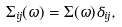<formula> <loc_0><loc_0><loc_500><loc_500>\Sigma _ { i j } ( \omega ) = \Sigma ( \omega ) \delta _ { i j } ,</formula> 